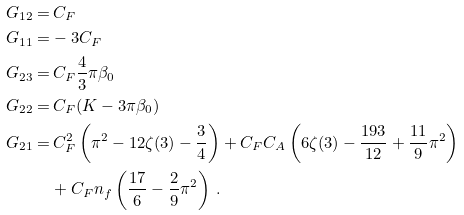<formula> <loc_0><loc_0><loc_500><loc_500>G _ { 1 2 } = & \, C _ { F } \\ \, G _ { 1 1 } = & - 3 C _ { F } \\ \, G _ { 2 3 } = & \, C _ { F } \frac { 4 } { 3 } \pi \beta _ { 0 } \\ \, G _ { 2 2 } = & \, C _ { F } ( K - 3 \pi \beta _ { 0 } ) \\ \, G _ { 2 1 } = & \, C _ { F } ^ { 2 } \left ( \pi ^ { 2 } - 1 2 \zeta ( 3 ) - \frac { 3 } { 4 } \right ) + C _ { F } C _ { A } \left ( 6 \zeta ( 3 ) - \frac { 1 9 3 } { 1 2 } + \frac { 1 1 } { 9 } \pi ^ { 2 } \right ) \\ & + C _ { F } n _ { f } \left ( \frac { 1 7 } { 6 } - \frac { 2 } { 9 } \pi ^ { 2 } \right ) \, .</formula> 